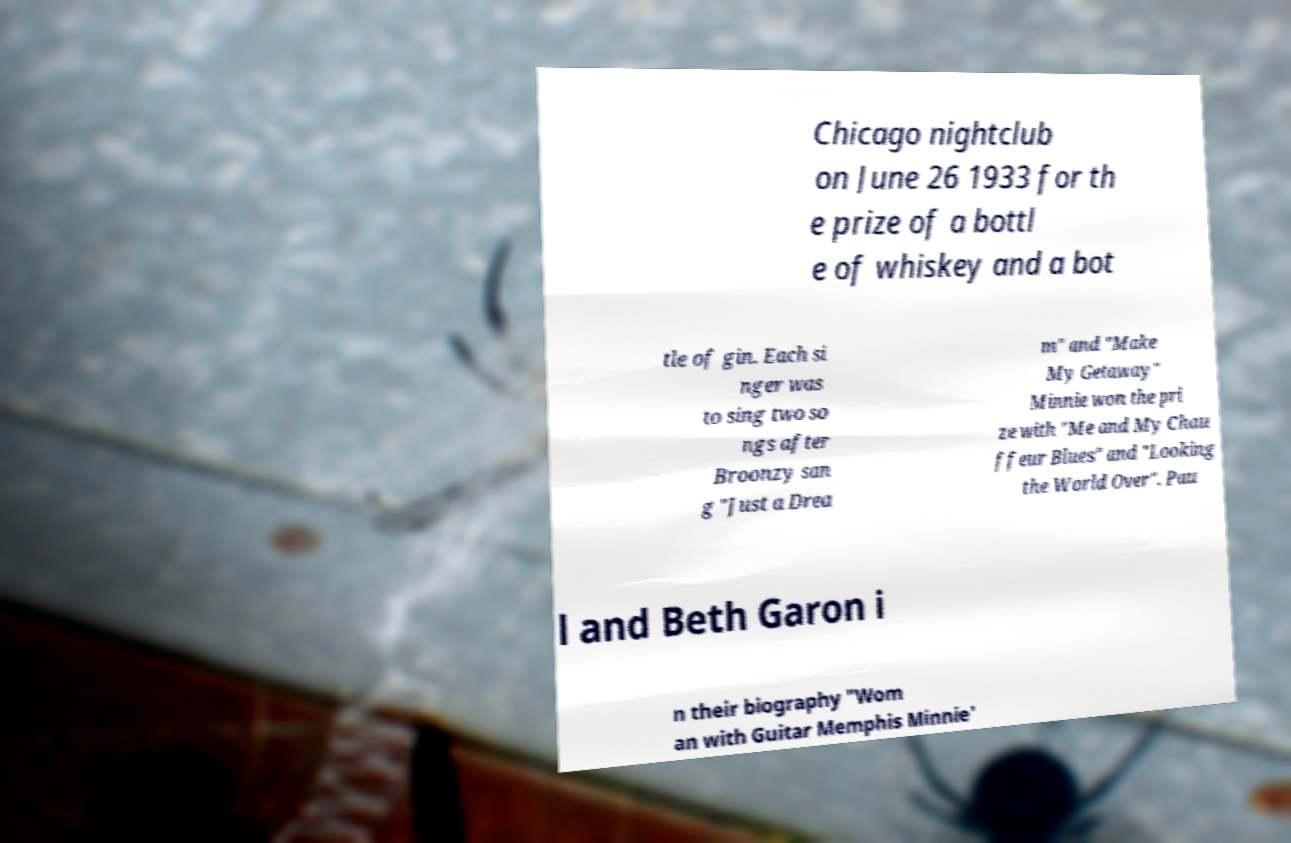For documentation purposes, I need the text within this image transcribed. Could you provide that? Chicago nightclub on June 26 1933 for th e prize of a bottl e of whiskey and a bot tle of gin. Each si nger was to sing two so ngs after Broonzy san g "Just a Drea m" and "Make My Getaway" Minnie won the pri ze with "Me and My Chau ffeur Blues" and "Looking the World Over". Pau l and Beth Garon i n their biography "Wom an with Guitar Memphis Minnie' 